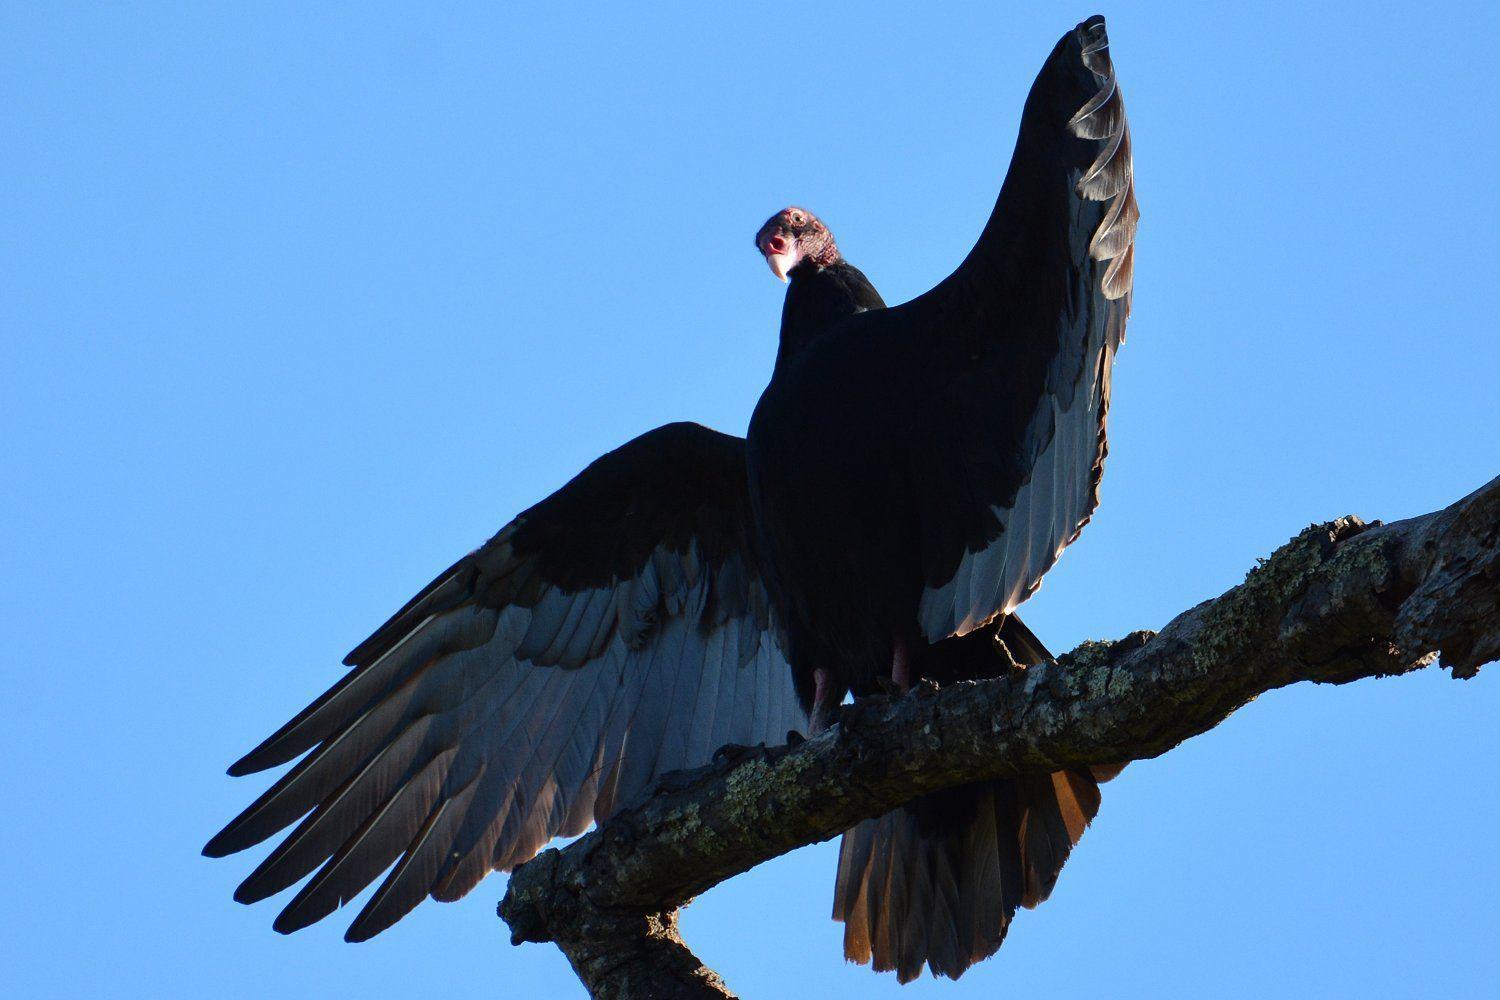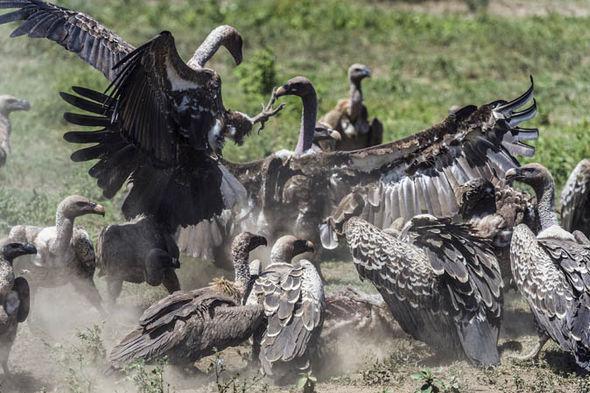The first image is the image on the left, the second image is the image on the right. For the images shown, is this caption "there is exactly one bird in the image on the left" true? Answer yes or no. Yes. The first image is the image on the left, the second image is the image on the right. Analyze the images presented: Is the assertion "At least one of the images contains exactly one bird." valid? Answer yes or no. Yes. 